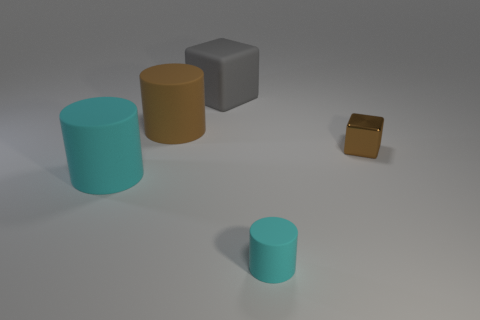Add 5 tiny brown blocks. How many objects exist? 10 Subtract all cylinders. How many objects are left? 2 Subtract 0 cyan spheres. How many objects are left? 5 Subtract all small cyan rubber cylinders. Subtract all tiny rubber objects. How many objects are left? 3 Add 2 rubber blocks. How many rubber blocks are left? 3 Add 2 blue cylinders. How many blue cylinders exist? 2 